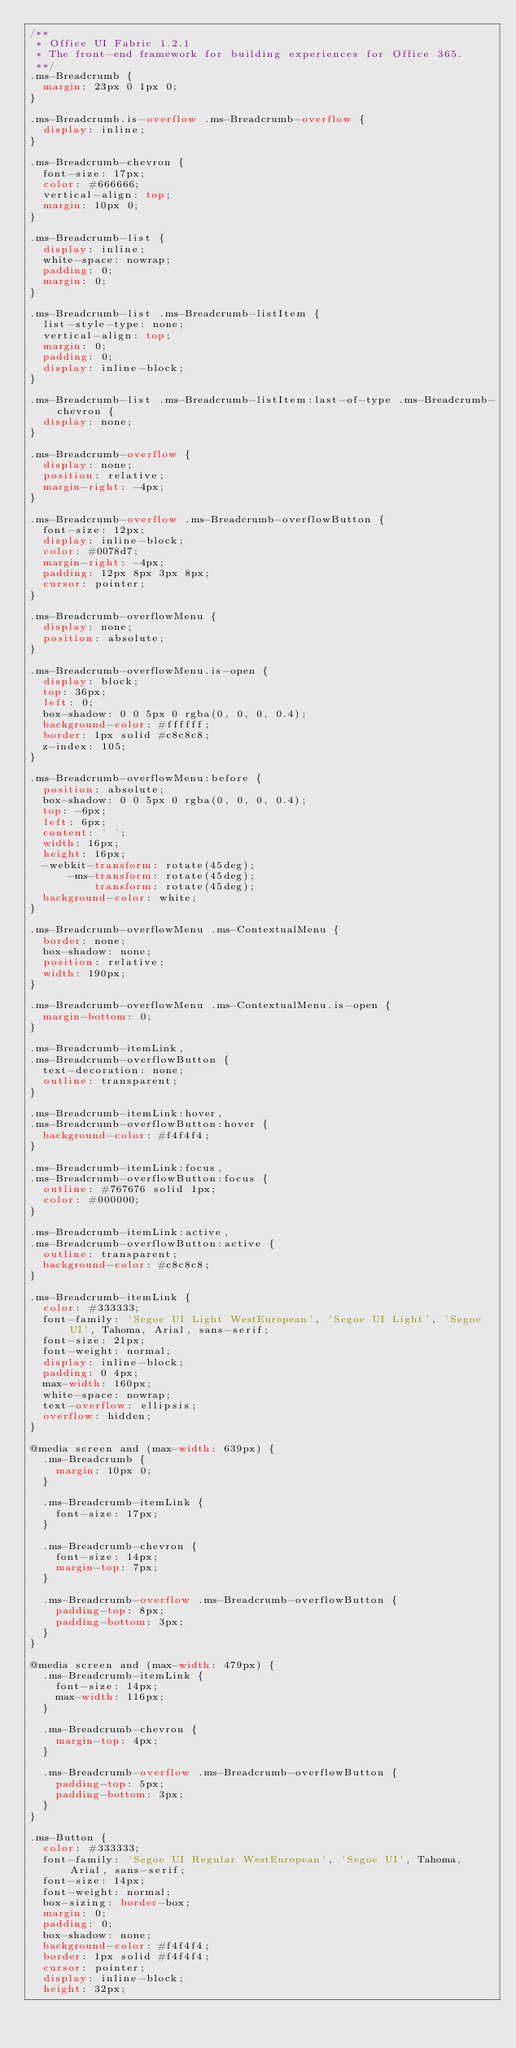Convert code to text. <code><loc_0><loc_0><loc_500><loc_500><_CSS_>/**
 * Office UI Fabric 1.2.1
 * The front-end framework for building experiences for Office 365.
 **/
.ms-Breadcrumb {
  margin: 23px 0 1px 0;
}

.ms-Breadcrumb.is-overflow .ms-Breadcrumb-overflow {
  display: inline;
}

.ms-Breadcrumb-chevron {
  font-size: 17px;
  color: #666666;
  vertical-align: top;
  margin: 10px 0;
}

.ms-Breadcrumb-list {
  display: inline;
  white-space: nowrap;
  padding: 0;
  margin: 0;
}

.ms-Breadcrumb-list .ms-Breadcrumb-listItem {
  list-style-type: none;
  vertical-align: top;
  margin: 0;
  padding: 0;
  display: inline-block;
}

.ms-Breadcrumb-list .ms-Breadcrumb-listItem:last-of-type .ms-Breadcrumb-chevron {
  display: none;
}

.ms-Breadcrumb-overflow {
  display: none;
  position: relative;
  margin-right: -4px;
}

.ms-Breadcrumb-overflow .ms-Breadcrumb-overflowButton {
  font-size: 12px;
  display: inline-block;
  color: #0078d7;
  margin-right: -4px;
  padding: 12px 8px 3px 8px;
  cursor: pointer;
}

.ms-Breadcrumb-overflowMenu {
  display: none;
  position: absolute;
}

.ms-Breadcrumb-overflowMenu.is-open {
  display: block;
  top: 36px;
  left: 0;
  box-shadow: 0 0 5px 0 rgba(0, 0, 0, 0.4);
  background-color: #ffffff;
  border: 1px solid #c8c8c8;
  z-index: 105;
}

.ms-Breadcrumb-overflowMenu:before {
  position: absolute;
  box-shadow: 0 0 5px 0 rgba(0, 0, 0, 0.4);
  top: -6px;
  left: 6px;
  content: ' ';
  width: 16px;
  height: 16px;
  -webkit-transform: rotate(45deg);
      -ms-transform: rotate(45deg);
          transform: rotate(45deg);
  background-color: white;
}

.ms-Breadcrumb-overflowMenu .ms-ContextualMenu {
  border: none;
  box-shadow: none;
  position: relative;
  width: 190px;
}

.ms-Breadcrumb-overflowMenu .ms-ContextualMenu.is-open {
  margin-bottom: 0;
}

.ms-Breadcrumb-itemLink,
.ms-Breadcrumb-overflowButton {
  text-decoration: none;
  outline: transparent;
}

.ms-Breadcrumb-itemLink:hover,
.ms-Breadcrumb-overflowButton:hover {
  background-color: #f4f4f4;
}

.ms-Breadcrumb-itemLink:focus,
.ms-Breadcrumb-overflowButton:focus {
  outline: #767676 solid 1px;
  color: #000000;
}

.ms-Breadcrumb-itemLink:active,
.ms-Breadcrumb-overflowButton:active {
  outline: transparent;
  background-color: #c8c8c8;
}

.ms-Breadcrumb-itemLink {
  color: #333333;
  font-family: 'Segoe UI Light WestEuropean', 'Segoe UI Light', 'Segoe UI', Tahoma, Arial, sans-serif;
  font-size: 21px;
  font-weight: normal;
  display: inline-block;
  padding: 0 4px;
  max-width: 160px;
  white-space: nowrap;
  text-overflow: ellipsis;
  overflow: hidden;
}

@media screen and (max-width: 639px) {
  .ms-Breadcrumb {
    margin: 10px 0;
  }

  .ms-Breadcrumb-itemLink {
    font-size: 17px;
  }

  .ms-Breadcrumb-chevron {
    font-size: 14px;
    margin-top: 7px;
  }

  .ms-Breadcrumb-overflow .ms-Breadcrumb-overflowButton {
    padding-top: 8px;
    padding-bottom: 3px;
  }
}

@media screen and (max-width: 479px) {
  .ms-Breadcrumb-itemLink {
    font-size: 14px;
    max-width: 116px;
  }

  .ms-Breadcrumb-chevron {
    margin-top: 4px;
  }

  .ms-Breadcrumb-overflow .ms-Breadcrumb-overflowButton {
    padding-top: 5px;
    padding-bottom: 3px;
  }
}

.ms-Button {
  color: #333333;
  font-family: 'Segoe UI Regular WestEuropean', 'Segoe UI', Tahoma, Arial, sans-serif;
  font-size: 14px;
  font-weight: normal;
  box-sizing: border-box;
  margin: 0;
  padding: 0;
  box-shadow: none;
  background-color: #f4f4f4;
  border: 1px solid #f4f4f4;
  cursor: pointer;
  display: inline-block;
  height: 32px;</code> 